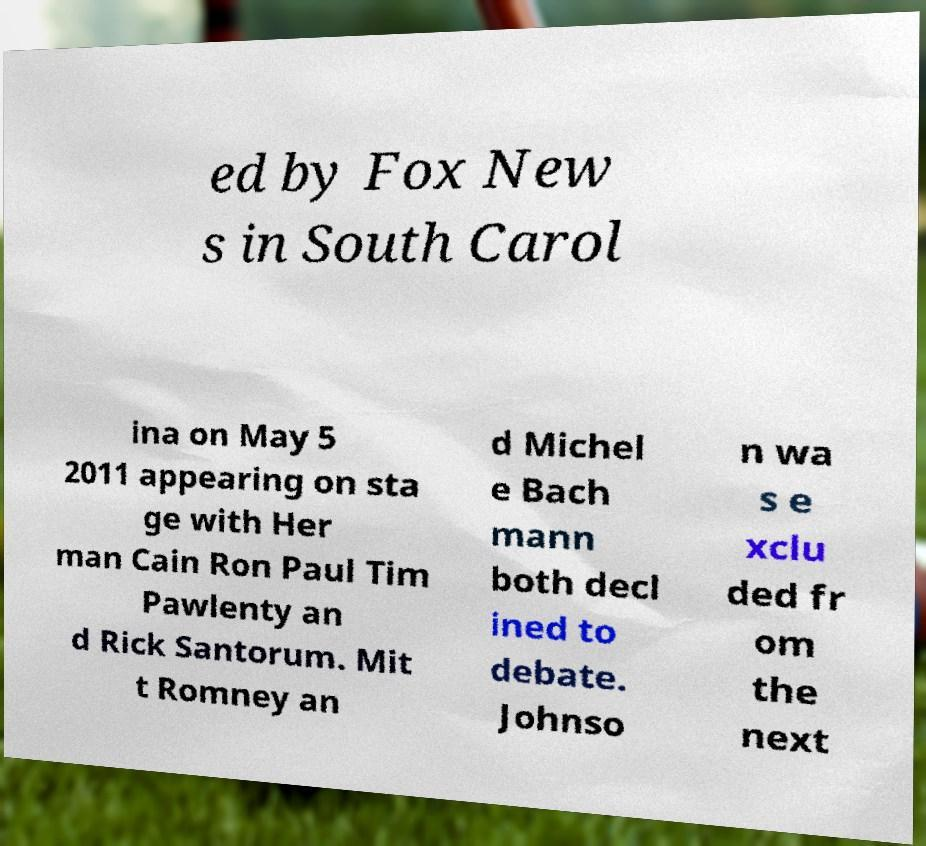Could you assist in decoding the text presented in this image and type it out clearly? ed by Fox New s in South Carol ina on May 5 2011 appearing on sta ge with Her man Cain Ron Paul Tim Pawlenty an d Rick Santorum. Mit t Romney an d Michel e Bach mann both decl ined to debate. Johnso n wa s e xclu ded fr om the next 